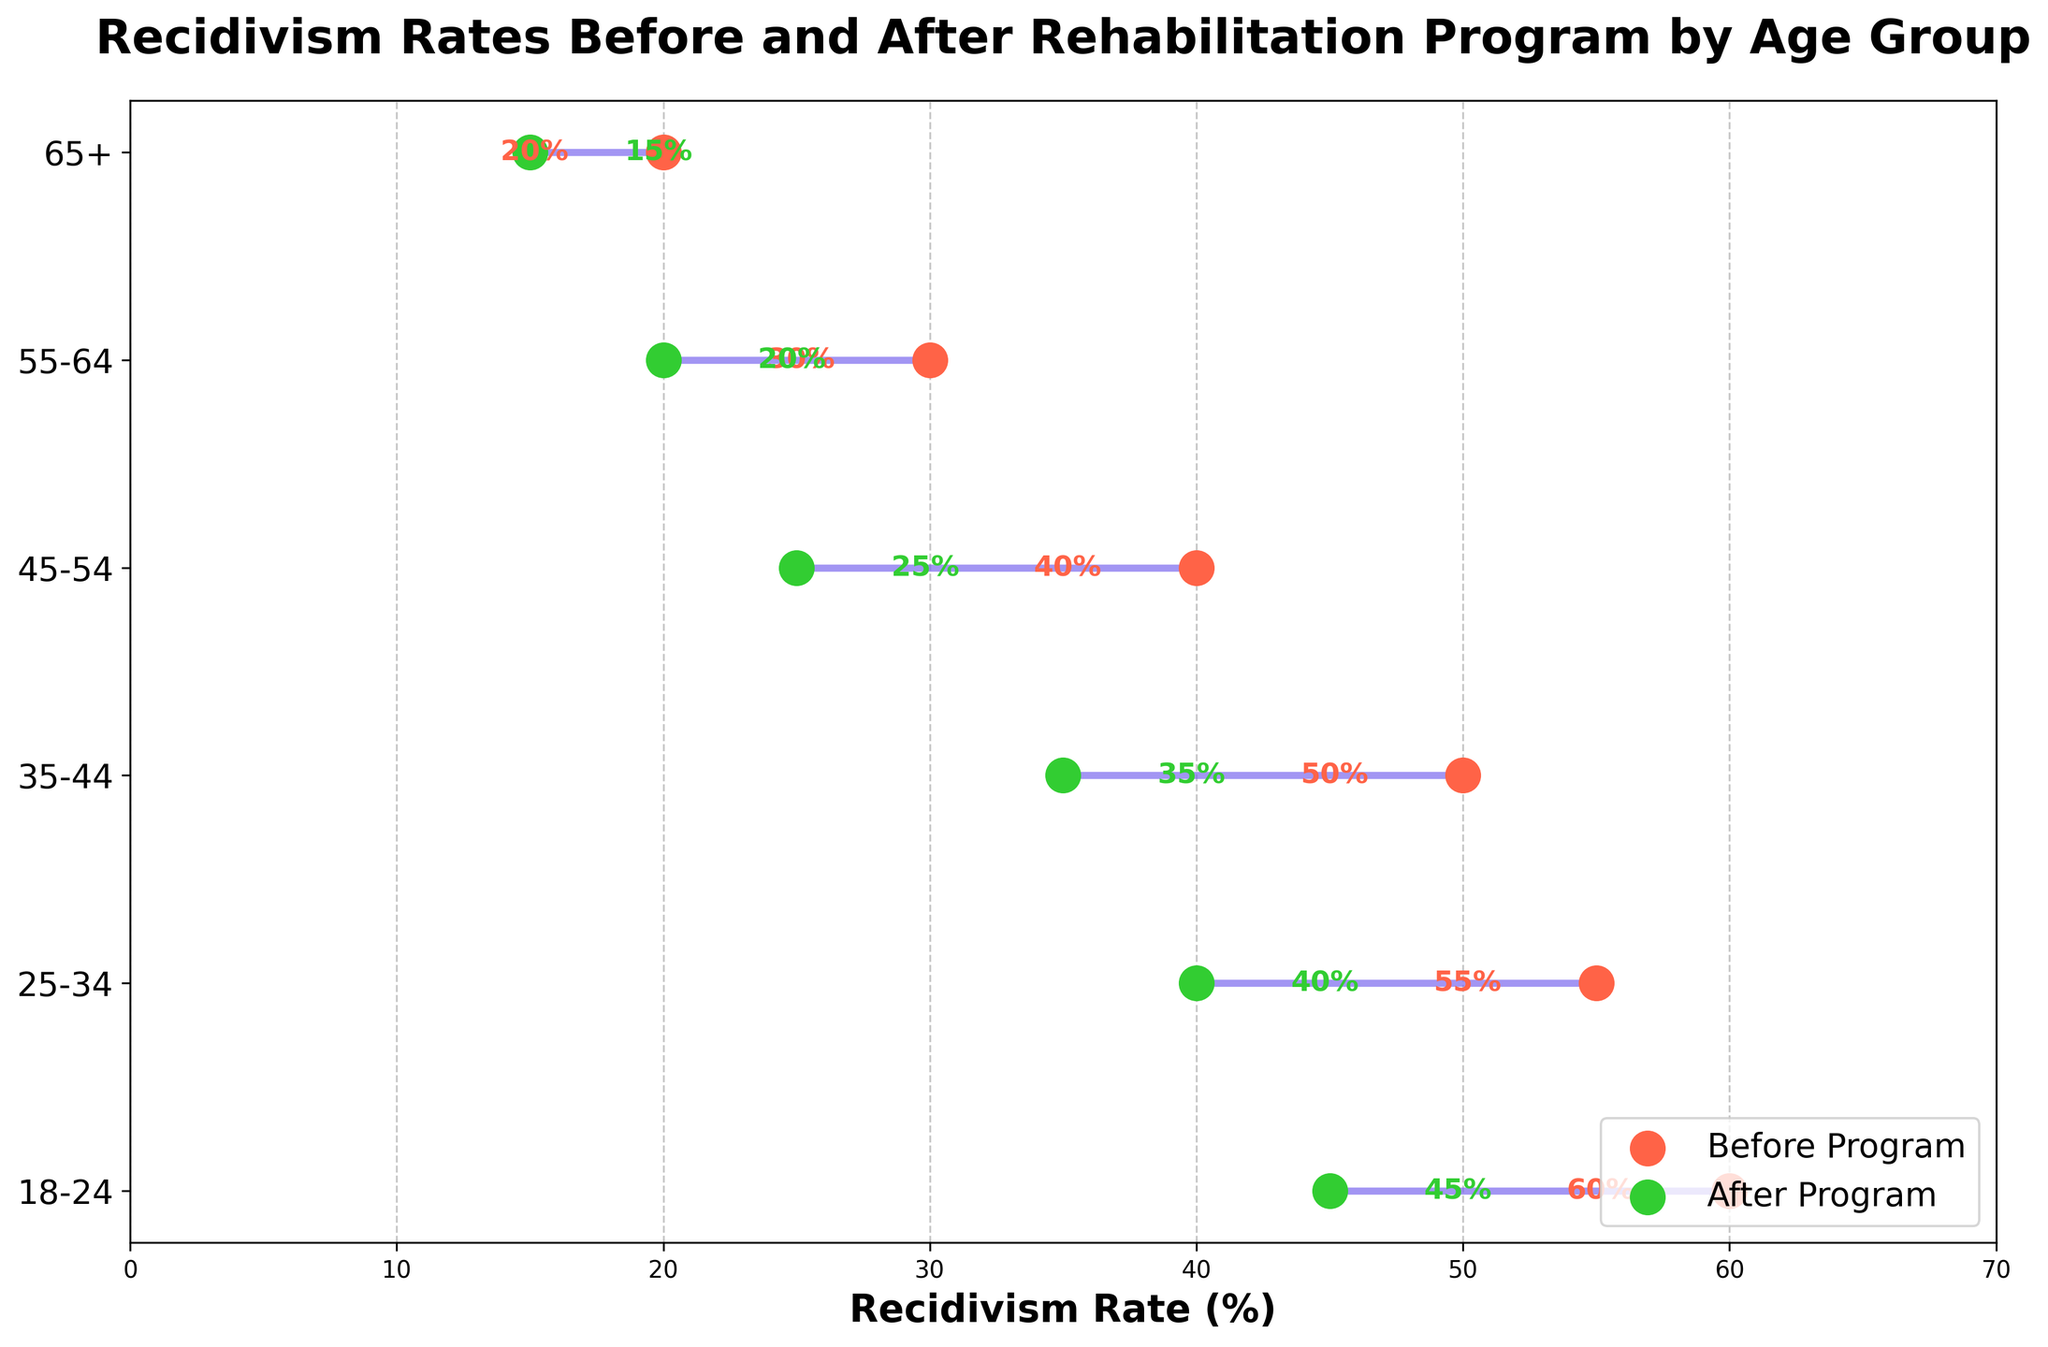What is the title of the plot? The title is displayed at the top of the plot, it reads "Recidivism Rates Before and After Rehabilitation Program by Age Group".
Answer: Recidivism Rates Before and After Rehabilitation Program by Age Group What is the recidivism rate for the 18-24 age group after the rehabilitation program? Look for the green dot on the dumbbell plot corresponding to the 18-24 age group, it is labeled with "45 %".
Answer: 45% Which age group shows the greatest decrease in recidivism rates after the rehabilitation program? Compare the differences between the before and after rates for each age group, the 45-54 age group shows the largest decrease from 40% to 25%, a drop of 15%.
Answer: 45-54 What are the two age groups with the lowest recidivism rates after the rehabilitation program? Examine the green dots for the lowest values, the 55-64 age group has 20% and the 65+ age group has 15%.
Answer: 55-64, 65+ How much did the recidivism rate decrease for the 35-44 age group after the rehabilitation program? Subtract the after rate (35%) from the before rate (50%) for the 35-44 age group. 50% - 35% = 15%.
Answer: 15% Which age group has the highest recidivism rate before the rehabilitation program? Look for the highest red dot value, which is at the 18-24 age group with 60%.
Answer: 18-24 What is the overall trend in recidivism rates after the rehabilitation program across different age groups? Observe the green dots compared to the red dots for each age group, all age groups show a decrease in recidivism rates.
Answer: Decreasing For the 25-34 age group, how does the recidivism rate after the program compare to the 45-54 age group's rate before the program? Look at the green dot for the 25-34 age group which is at 40%, and compare it to the red dot for the 45-54 age group at 40%, they are equal.
Answer: Equal By how much did the recidivism rate of the 55-64 age group decrease after the program? Subtract the after rate (20%) from the before rate (30%) for the 55-64 age group. 30% - 20% = 10%.
Answer: 10% 